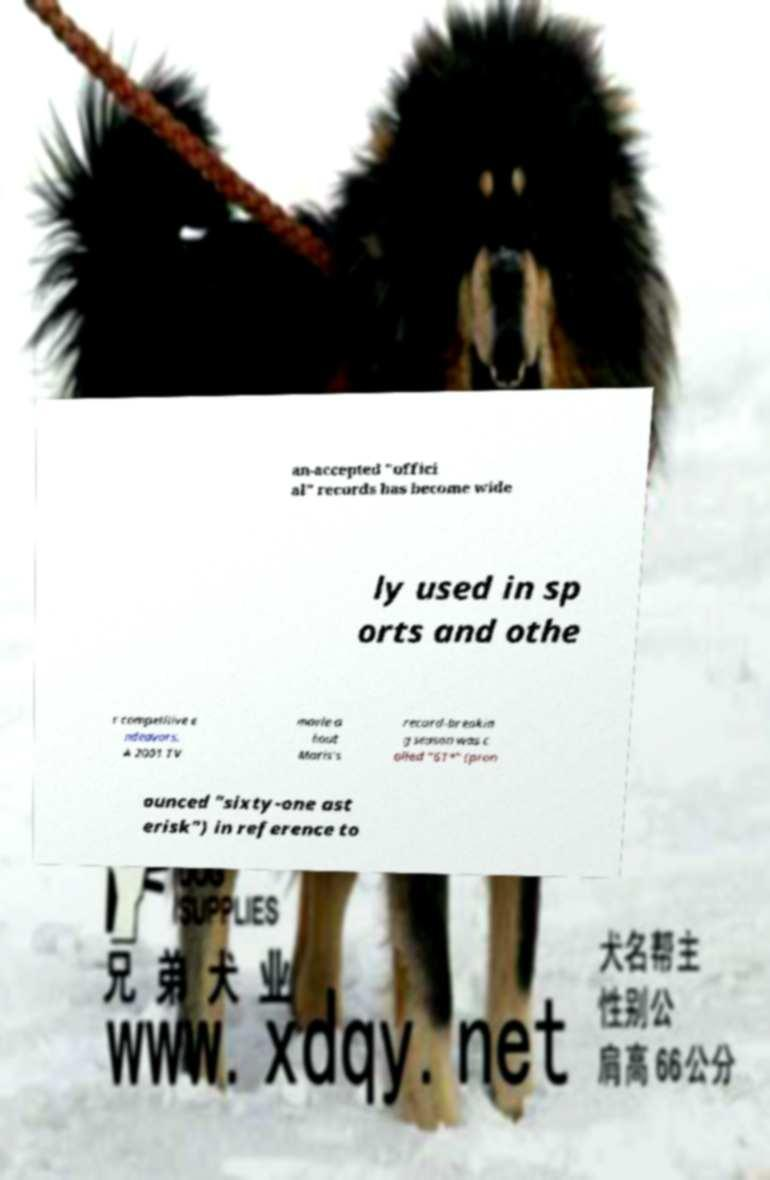For documentation purposes, I need the text within this image transcribed. Could you provide that? an-accepted "offici al" records has become wide ly used in sp orts and othe r competitive e ndeavors. A 2001 TV movie a bout Maris's record-breakin g season was c alled "61*" (pron ounced "sixty-one ast erisk") in reference to 